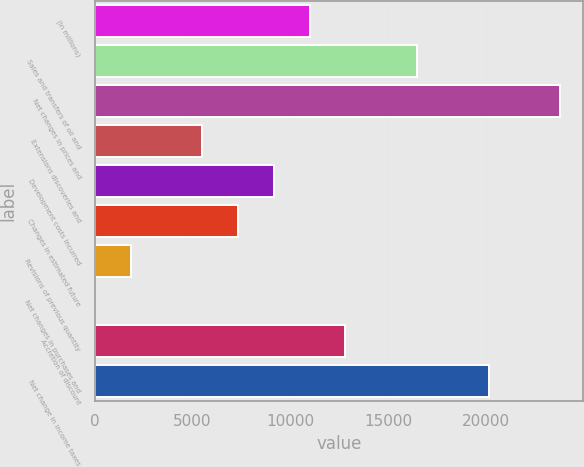<chart> <loc_0><loc_0><loc_500><loc_500><bar_chart><fcel>(In millions)<fcel>Sales and transfers of oil and<fcel>Net changes in prices and<fcel>Extensions discoveries and<fcel>Development costs incurred<fcel>Changes in estimated future<fcel>Revisions of previous quantity<fcel>Net changes in purchases and<fcel>Accretion of discount<fcel>Net change in income taxes<nl><fcel>10979.2<fcel>16462.3<fcel>23773.1<fcel>5496.1<fcel>9151.5<fcel>7323.8<fcel>1840.7<fcel>13<fcel>12806.9<fcel>20117.7<nl></chart> 